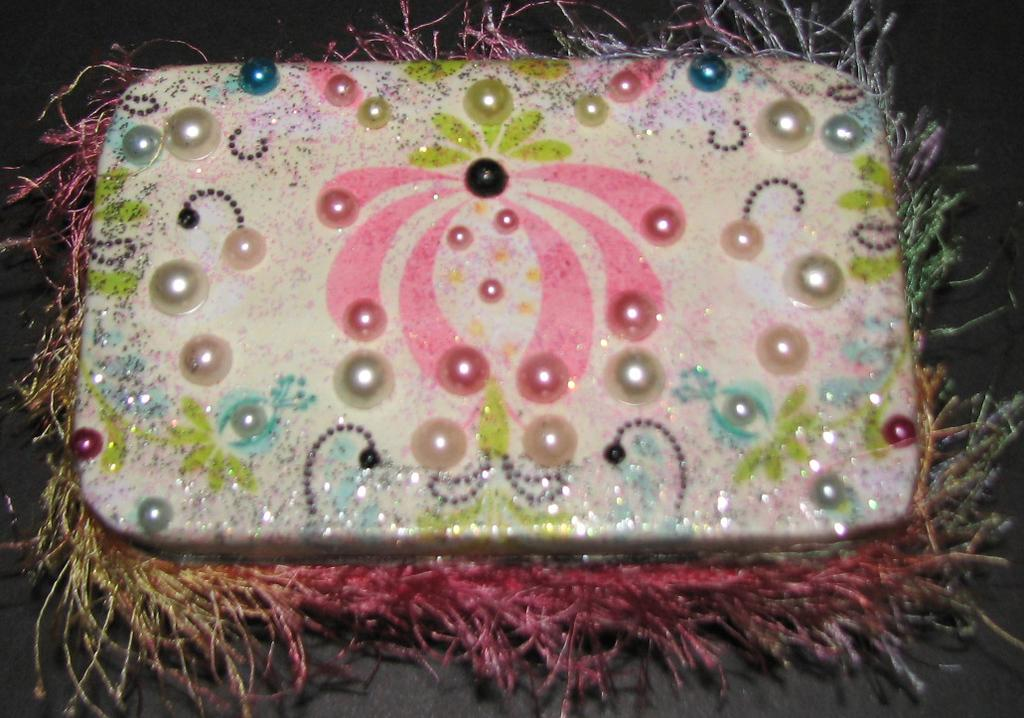What is the main subject of the image? There is a colorful object in the image. What are the pearls in the image like? There are colorful pearls in the image. What color is the background of the image? The background of the image is black. How many boats are visible in the image? There are no boats present in the image. What type of collar is on the colorful object in the image? There is no collar on the colorful object in the image. 